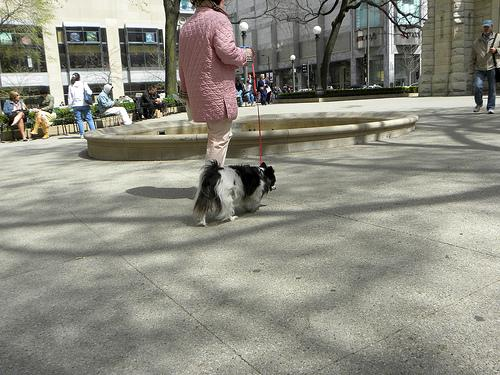Count the number of people in the image. There are six people in the image. What type of shoes is the woman with yellow boots wearing? The woman is wearing yellow boots. What objects are casting shadows on the concrete walkway? Tree limb shadows are cast upon the concrete walkway. How many women are sitting on the bench, and describe their position? Two women are sitting on the bench, crossing their legs. Describe the appearance of the sidewalk in the image. The sidewalk is a salt and pepper textured concrete slab with shadows from tree limbs. Tell me the color and style of the outerwear worn by the man walking towards the woman. The man is wearing a blue cap, a tan jacket, and a hoodie. What does the black and white dog have in its mouth? The black and white dog does not have anything in its mouth. Identify the type of coat worn by the woman walking her dog. The woman is wearing a heavy pink winter coat. Find out the color of the leash attached to the dog. The leash attached to the dog is red. Is the man walking towards the woman wearing anything on his head? Yes, the man is walking towards the woman wearing a baseball hat. Can you find a tree with leaves in the park? There is only one mention of a tree in the park, which has bare branches, and no leaves are mentioned. Is the leash attached to the dog blue? There are several mentions of a red leash attached to the dog, but none of a blue leash. Is there a person wearing a purple coat? No one in the image is wearing a purple coat; there are mentions of a person wearing a pink coat, a pink jacket, and a white jacket, but not purple. Is the man wearing a green cap? There is no mention of a man wearing a green cap, only a man wearing a blue cap and a man wearing a baseball hat. Are there three women sitting on a bench talking? There are only two women mentioned as sitting on a bench and talking, not three. Can you see a brown dog in the image? There is no mention of a brown dog in the image; instead, there are several references to a black and white dog. 